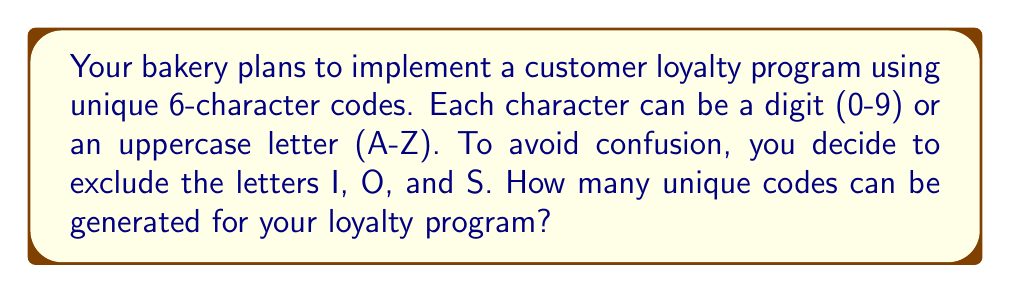Could you help me with this problem? Let's approach this step-by-step:

1) First, we need to determine how many characters we can use for each position in the code:
   - 10 digits (0-9)
   - 26 letters, but excluding I, O, and S: 26 - 3 = 23 letters
   - Total characters available: 10 + 23 = 33

2) Now, we need to calculate how many ways we can fill each of the 6 positions in the code. This is a case of permutation with repetition allowed.

3) For each position, we have 33 choices, and this is true for all 6 positions.

4) The formula for permutation with repetition is:

   $$ n^r $$

   Where $n$ is the number of choices for each position, and $r$ is the number of positions.

5) In this case, $n = 33$ and $r = 6$. So, we calculate:

   $$ 33^6 = 1,291,467,969 $$

Therefore, the total number of unique codes that can be generated is 1,291,467,969.
Answer: 1,291,467,969 